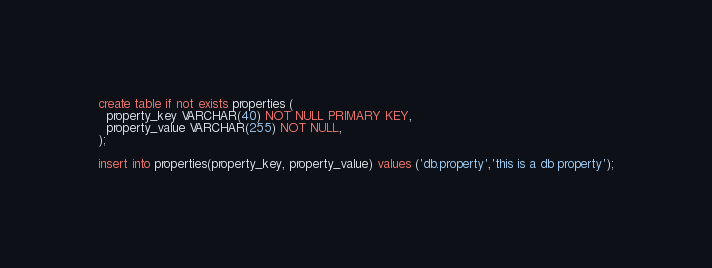<code> <loc_0><loc_0><loc_500><loc_500><_SQL_>create table if not exists properties (
  property_key VARCHAR(40) NOT NULL PRIMARY KEY,
  property_value VARCHAR(255) NOT NULL,
);

insert into properties(property_key, property_value) values ('db.property','this is a db property');</code> 